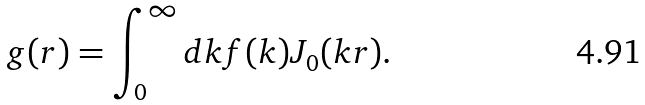Convert formula to latex. <formula><loc_0><loc_0><loc_500><loc_500>g ( r ) = \int _ { 0 } ^ { \infty } d k f ( k ) J _ { 0 } ( k r ) .</formula> 